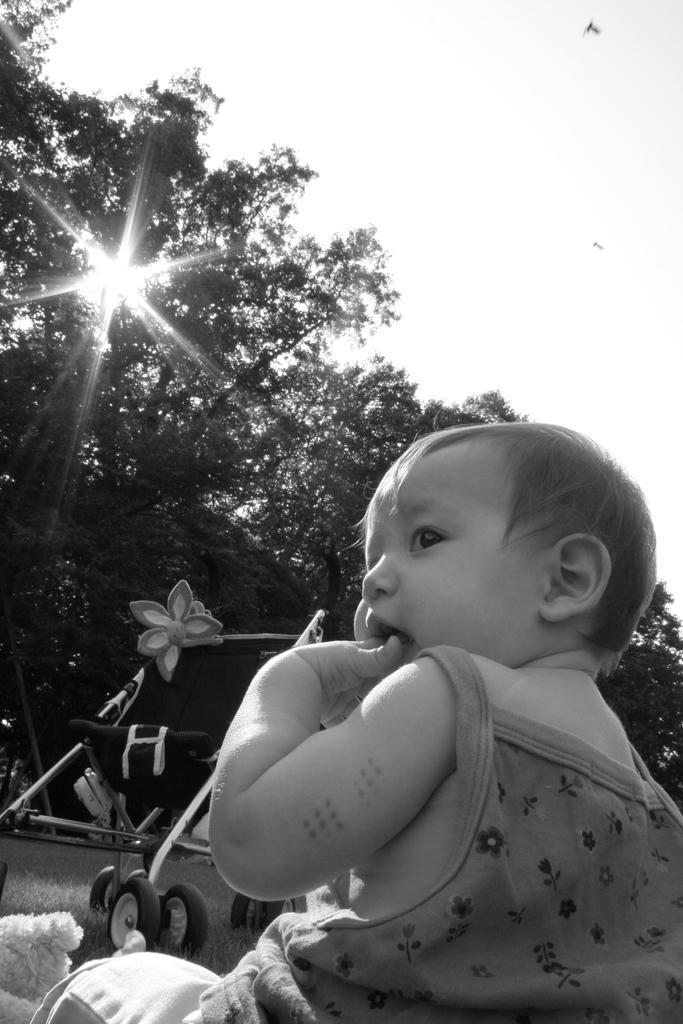How would you summarize this image in a sentence or two? In this picture we can see a child, vehicle on the ground, trees and in the background we can see the sky. 